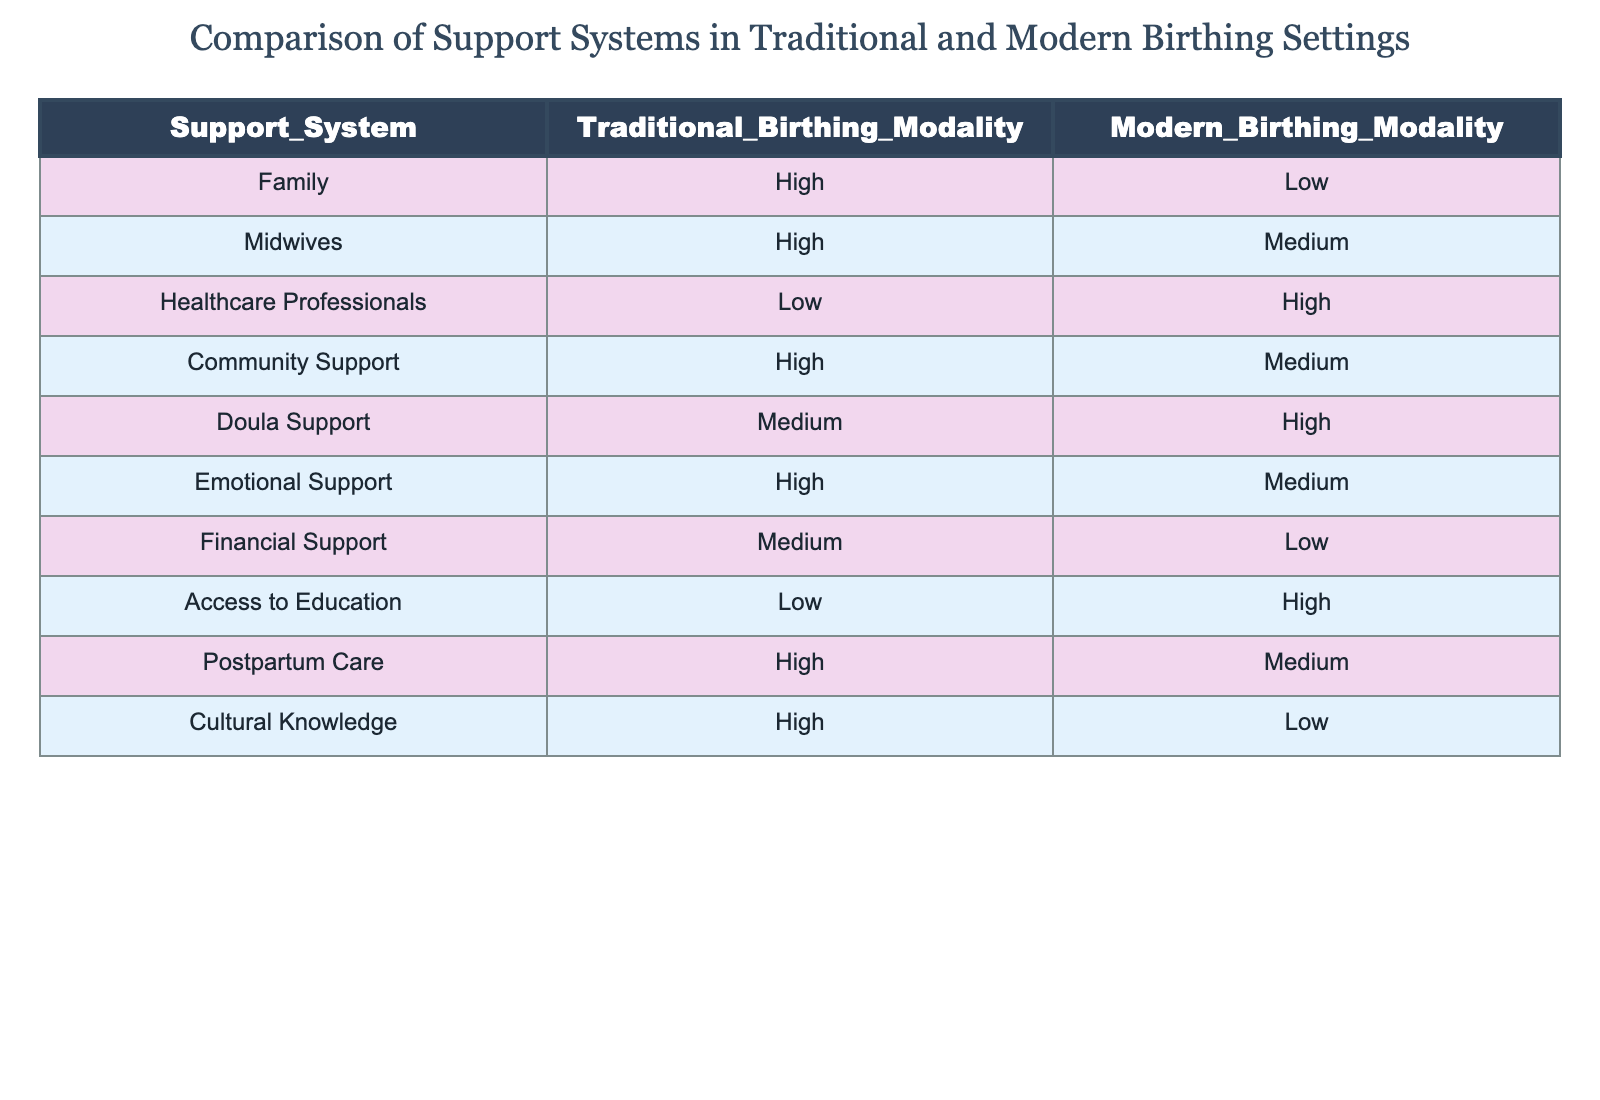What is the level of Family support in traditional birthing settings? According to the table, Family support in traditional birthing settings is categorized as High.
Answer: High Which support system has the lowest support level in modern birthing modalities? The table indicates that Healthcare Professionals have the lowest support level in modern birthing modalities, which is categorized as Low.
Answer: Low Is Doula support higher in traditional birthing modalities compared to modern birthing modalities? The table shows Doula support at Medium level in traditional birthing modalities and High in modern birthing modalities, thus Doula support is not higher in traditional settings.
Answer: No What is the difference in the support level for Cultural Knowledge between traditional and modern birthing settings? Cultural Knowledge is categorized as High in traditional birthing settings and Low in modern birthing settings. Therefore, the difference is High - Low = High.
Answer: High How many support systems are rated High in traditional birthing modalities? By looking at the traditional birthing rows, the support systems that rate High are Family, Midwives, Community Support, Emotional Support, Postpartum Care, and Cultural Knowledge. In total, there are 6 systems rated as High.
Answer: 6 Which support system has the highest level of support in traditional birthing settings? The table specifies that Family support is rated as High, and none other cited system appears as higher in the traditional category, thus Family has the highest support.
Answer: Family Are the support levels for Access to Education the same in both birthing modalities? The table indicates that Access to Education is rated Low in traditional birthing modalities and High in modern ones; hence they are not the same.
Answer: No What is the average support level for the support systems listed in modern birthing modalities? The support levels in modern modalities are Low, Medium, High, Medium, High, Medium, Low, High. Converting these to numerical values (Low=1, Medium=2, High=3) gives a total of (1 + 2 + 3 + 2 + 3 + 2 + 1 + 3) = 17. There are 8 support systems, thus the average is 17/8 = 2.125 which correlates to about Medium support.
Answer: Medium What support system shows an increase in support level when comparing traditional to modern birthing modalities? The table shows that Doula Support increases from Medium in traditional settings to High in modern settings, indicating an increase.
Answer: Doula Support 